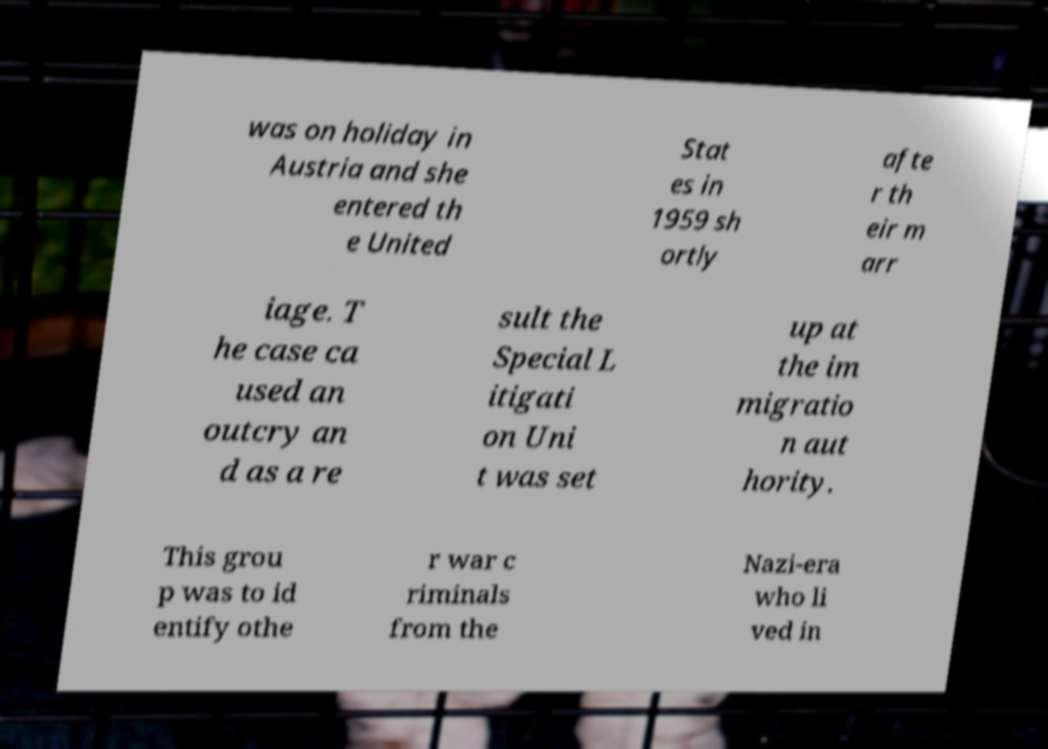Can you accurately transcribe the text from the provided image for me? was on holiday in Austria and she entered th e United Stat es in 1959 sh ortly afte r th eir m arr iage. T he case ca used an outcry an d as a re sult the Special L itigati on Uni t was set up at the im migratio n aut hority. This grou p was to id entify othe r war c riminals from the Nazi-era who li ved in 